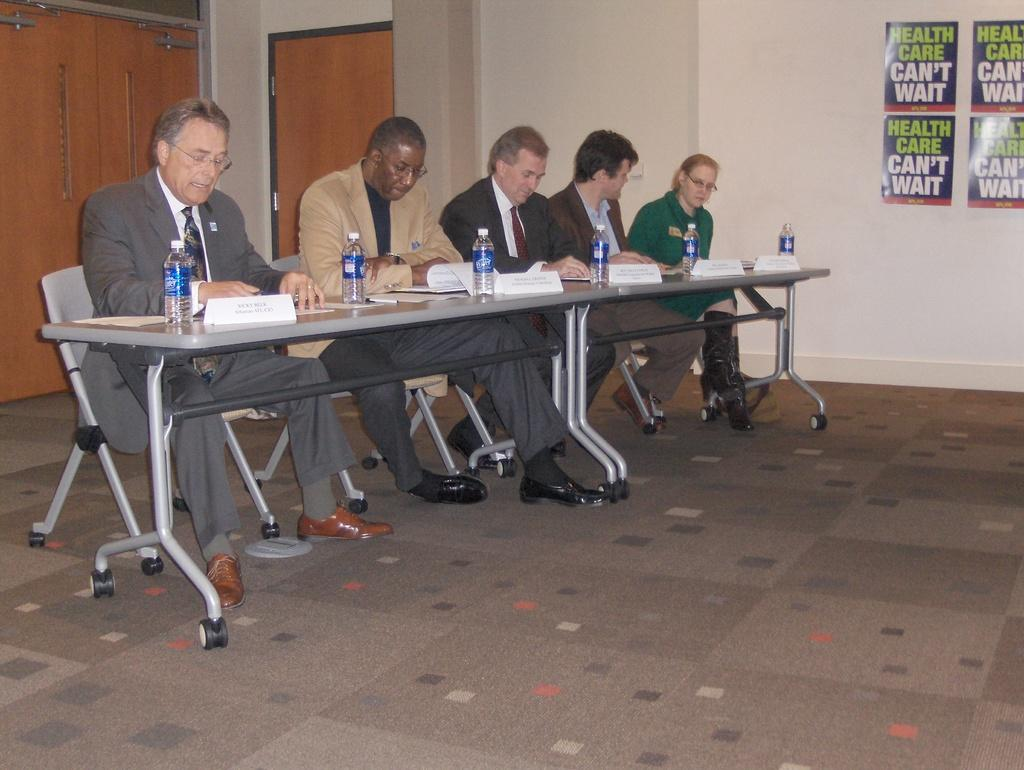How many people are sitting in the image? There are five persons sitting on chairs in the image. What is present on the table in the image? There is a paper, a name board, and a bottle on the table in the image. Can you describe the floor in the image? The floor is visible in the image. What can be seen in the background of the image? There is a wall in the background of the image, and there are posters on the wall. What type of noise can be heard coming from the road in the image? There is no road present in the image, so it is not possible to determine what, if any, noise might be heard. 